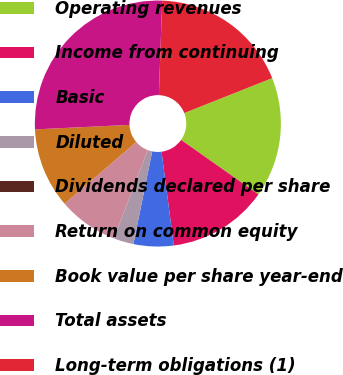Convert chart to OTSL. <chart><loc_0><loc_0><loc_500><loc_500><pie_chart><fcel>Operating revenues<fcel>Income from continuing<fcel>Basic<fcel>Diluted<fcel>Dividends declared per share<fcel>Return on common equity<fcel>Book value per share year-end<fcel>Total assets<fcel>Long-term obligations (1)<nl><fcel>15.79%<fcel>13.16%<fcel>5.26%<fcel>2.63%<fcel>0.0%<fcel>7.89%<fcel>10.53%<fcel>26.32%<fcel>18.42%<nl></chart> 